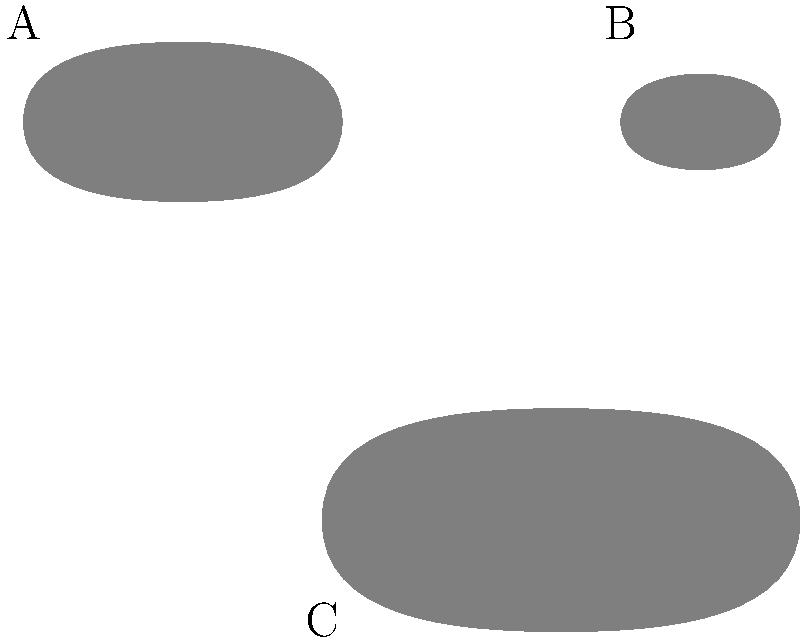Which of the fish silhouettes shown above represents the Hamour, a popular fish in Bahraini cuisine? To identify the Hamour fish from the given silhouettes, let's consider the characteristics of each:

1. Fish A: This silhouette shows a medium-sized fish with a slightly elongated body and a distinct hump on its back. These are typical features of the Hamour.

2. Fish B: This silhouette depicts a small, roundish fish with a more compact body shape. This is not characteristic of the Hamour.

3. Fish C: This silhouette shows a large fish with a very elongated body and a flattened head. While the Hamour can grow quite large, this shape is not typical for it.

Based on these observations, the fish that most closely resembles the Hamour is Fish A. The Hamour, also known as the Orange-spotted Grouper, is indeed characterized by its medium to large size and the distinctive hump on its back, which is clearly visible in silhouette A.

Hamour is a popular fish in Bahraini cuisine and is commonly found in the waters around Bahrain, making it a familiar sight for many residents, including senior citizens.
Answer: A 